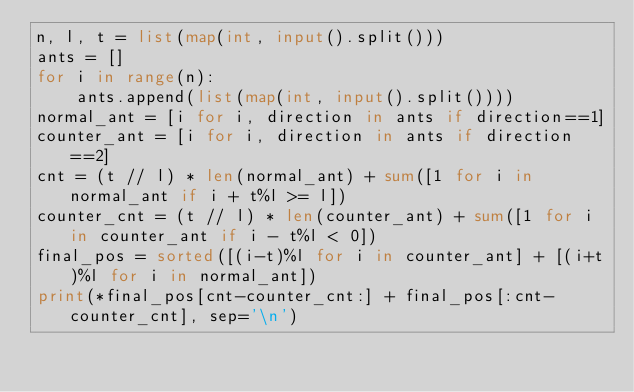<code> <loc_0><loc_0><loc_500><loc_500><_Python_>n, l, t = list(map(int, input().split()))
ants = []
for i in range(n):
    ants.append(list(map(int, input().split())))
normal_ant = [i for i, direction in ants if direction==1]
counter_ant = [i for i, direction in ants if direction==2]
cnt = (t // l) * len(normal_ant) + sum([1 for i in normal_ant if i + t%l >= l])
counter_cnt = (t // l) * len(counter_ant) + sum([1 for i in counter_ant if i - t%l < 0])
final_pos = sorted([(i-t)%l for i in counter_ant] + [(i+t)%l for i in normal_ant])
print(*final_pos[cnt-counter_cnt:] + final_pos[:cnt-counter_cnt], sep='\n')</code> 